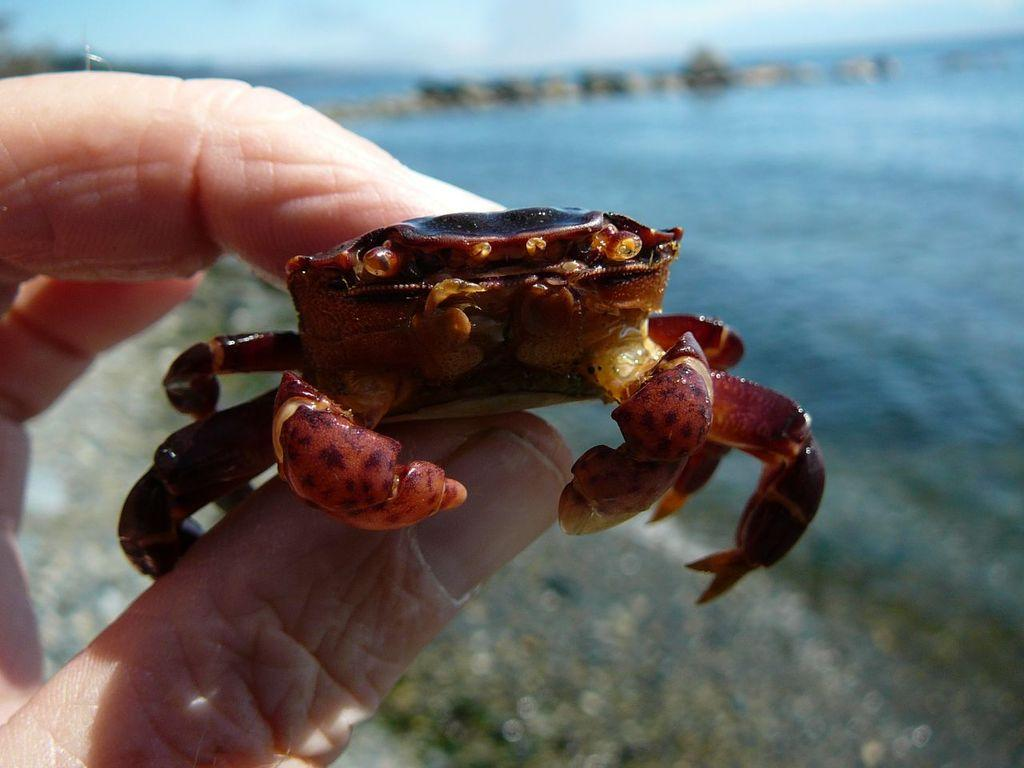What is the main subject of the image? There is a person in the image. What is the person holding in the image? The person is holding a crab. Can you describe the background of the image? The background of the image is blurry. What type of spoon can be seen in the image? There is no spoon present in the image. Is the person wearing a vest in the image? The provided facts do not mention a vest, so we cannot determine if the person is wearing one. 